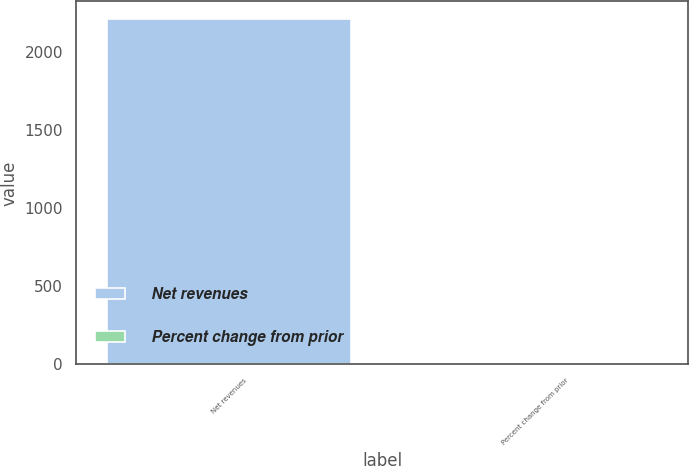Convert chart to OTSL. <chart><loc_0><loc_0><loc_500><loc_500><bar_chart><fcel>Net revenues<fcel>Percent change from prior<nl><fcel>2216<fcel>5<nl></chart> 